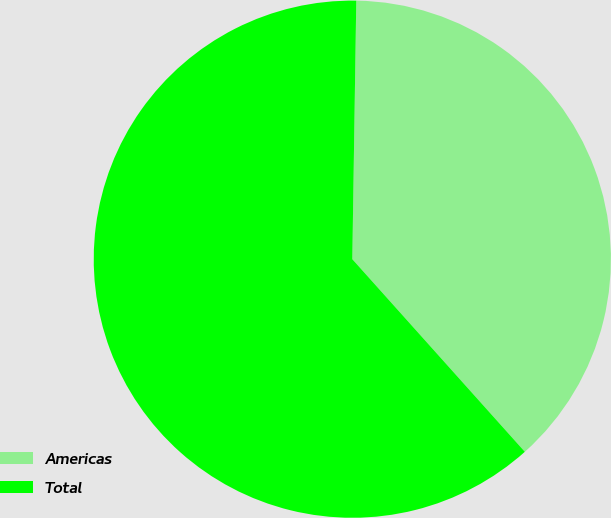Convert chart to OTSL. <chart><loc_0><loc_0><loc_500><loc_500><pie_chart><fcel>Americas<fcel>Total<nl><fcel>38.13%<fcel>61.87%<nl></chart> 